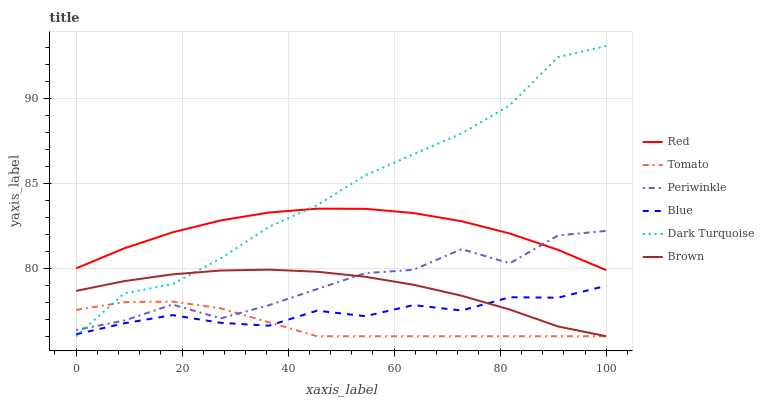Does Tomato have the minimum area under the curve?
Answer yes or no. Yes. Does Dark Turquoise have the maximum area under the curve?
Answer yes or no. Yes. Does Blue have the minimum area under the curve?
Answer yes or no. No. Does Blue have the maximum area under the curve?
Answer yes or no. No. Is Brown the smoothest?
Answer yes or no. Yes. Is Periwinkle the roughest?
Answer yes or no. Yes. Is Blue the smoothest?
Answer yes or no. No. Is Blue the roughest?
Answer yes or no. No. Does Blue have the lowest value?
Answer yes or no. No. Does Blue have the highest value?
Answer yes or no. No. Is Tomato less than Red?
Answer yes or no. Yes. Is Red greater than Tomato?
Answer yes or no. Yes. Does Tomato intersect Red?
Answer yes or no. No. 